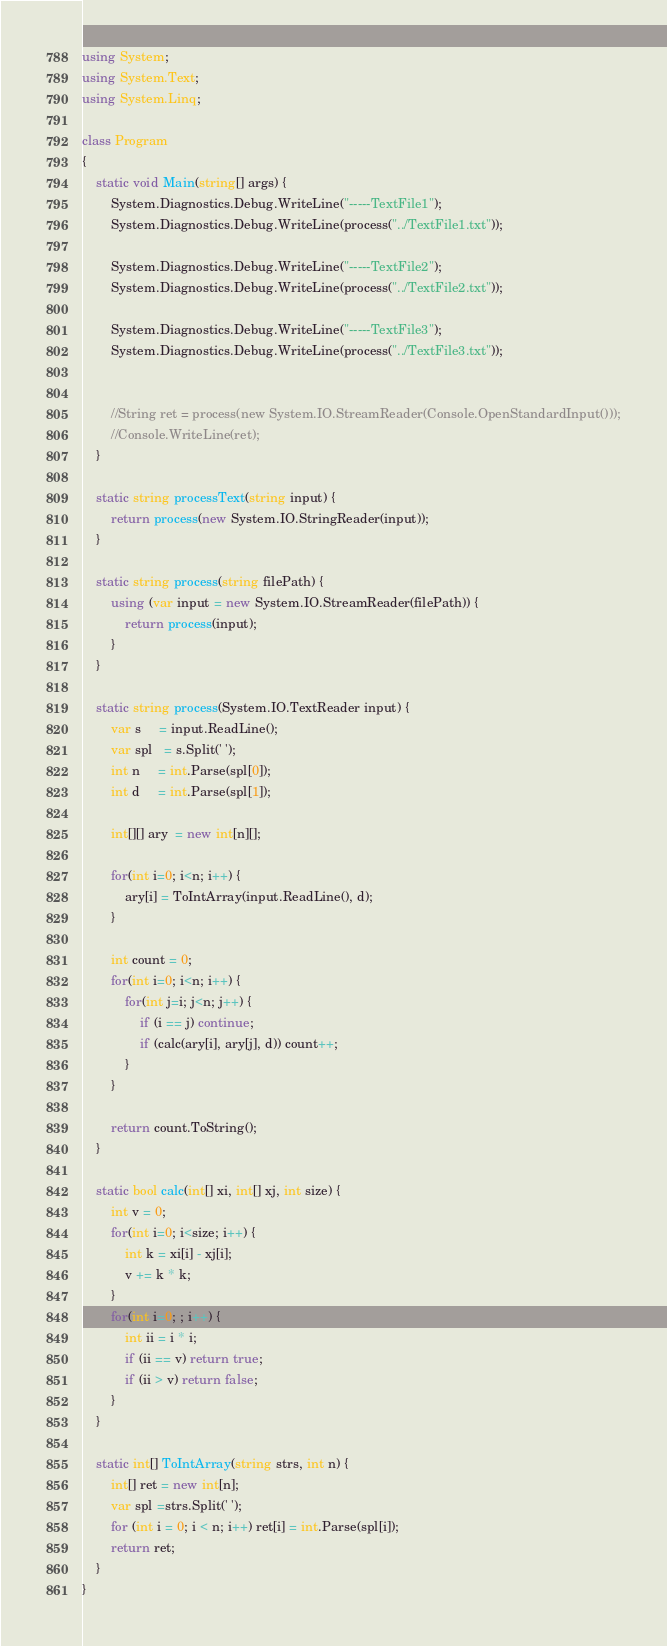Convert code to text. <code><loc_0><loc_0><loc_500><loc_500><_C#_>using System;
using System.Text;
using System.Linq;

class Program
{
    static void Main(string[] args) {
        System.Diagnostics.Debug.WriteLine("-----TextFile1");
        System.Diagnostics.Debug.WriteLine(process("../TextFile1.txt"));

        System.Diagnostics.Debug.WriteLine("-----TextFile2");
        System.Diagnostics.Debug.WriteLine(process("../TextFile2.txt"));

        System.Diagnostics.Debug.WriteLine("-----TextFile3");
        System.Diagnostics.Debug.WriteLine(process("../TextFile3.txt"));


        //String ret = process(new System.IO.StreamReader(Console.OpenStandardInput()));
        //Console.WriteLine(ret);
    }

    static string processText(string input) {
        return process(new System.IO.StringReader(input));
    }

    static string process(string filePath) {
        using (var input = new System.IO.StreamReader(filePath)) {
            return process(input);
        }
    }

    static string process(System.IO.TextReader input) {
        var s     = input.ReadLine();
        var spl   = s.Split(' ');
        int n     = int.Parse(spl[0]);
        int d     = int.Parse(spl[1]);

        int[][] ary  = new int[n][];

        for(int i=0; i<n; i++) {
            ary[i] = ToIntArray(input.ReadLine(), d);
        }

        int count = 0;
        for(int i=0; i<n; i++) {
            for(int j=i; j<n; j++) {
                if (i == j) continue;
                if (calc(ary[i], ary[j], d)) count++;
            }
        }

        return count.ToString();
    }

    static bool calc(int[] xi, int[] xj, int size) {
        int v = 0;
        for(int i=0; i<size; i++) {
            int k = xi[i] - xj[i];
            v += k * k;
        }
        for(int i=0; ; i++) {
            int ii = i * i;
            if (ii == v) return true;
            if (ii > v) return false;
        }
    }
    
    static int[] ToIntArray(string strs, int n) {
        int[] ret = new int[n];
        var spl =strs.Split(' ');
        for (int i = 0; i < n; i++) ret[i] = int.Parse(spl[i]);
        return ret;
    }
}
</code> 